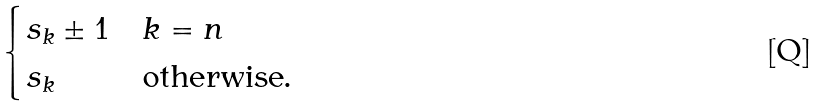Convert formula to latex. <formula><loc_0><loc_0><loc_500><loc_500>\begin{cases} s _ { k } \pm 1 & k = n \\ s _ { k } & \text {otherwise} . \end{cases}</formula> 